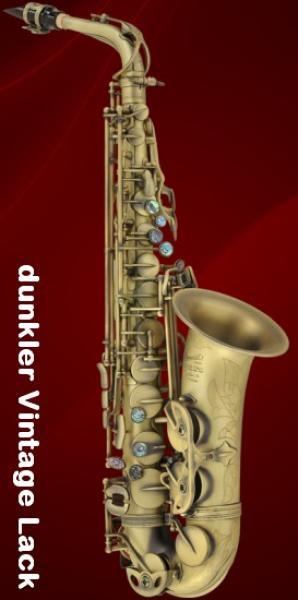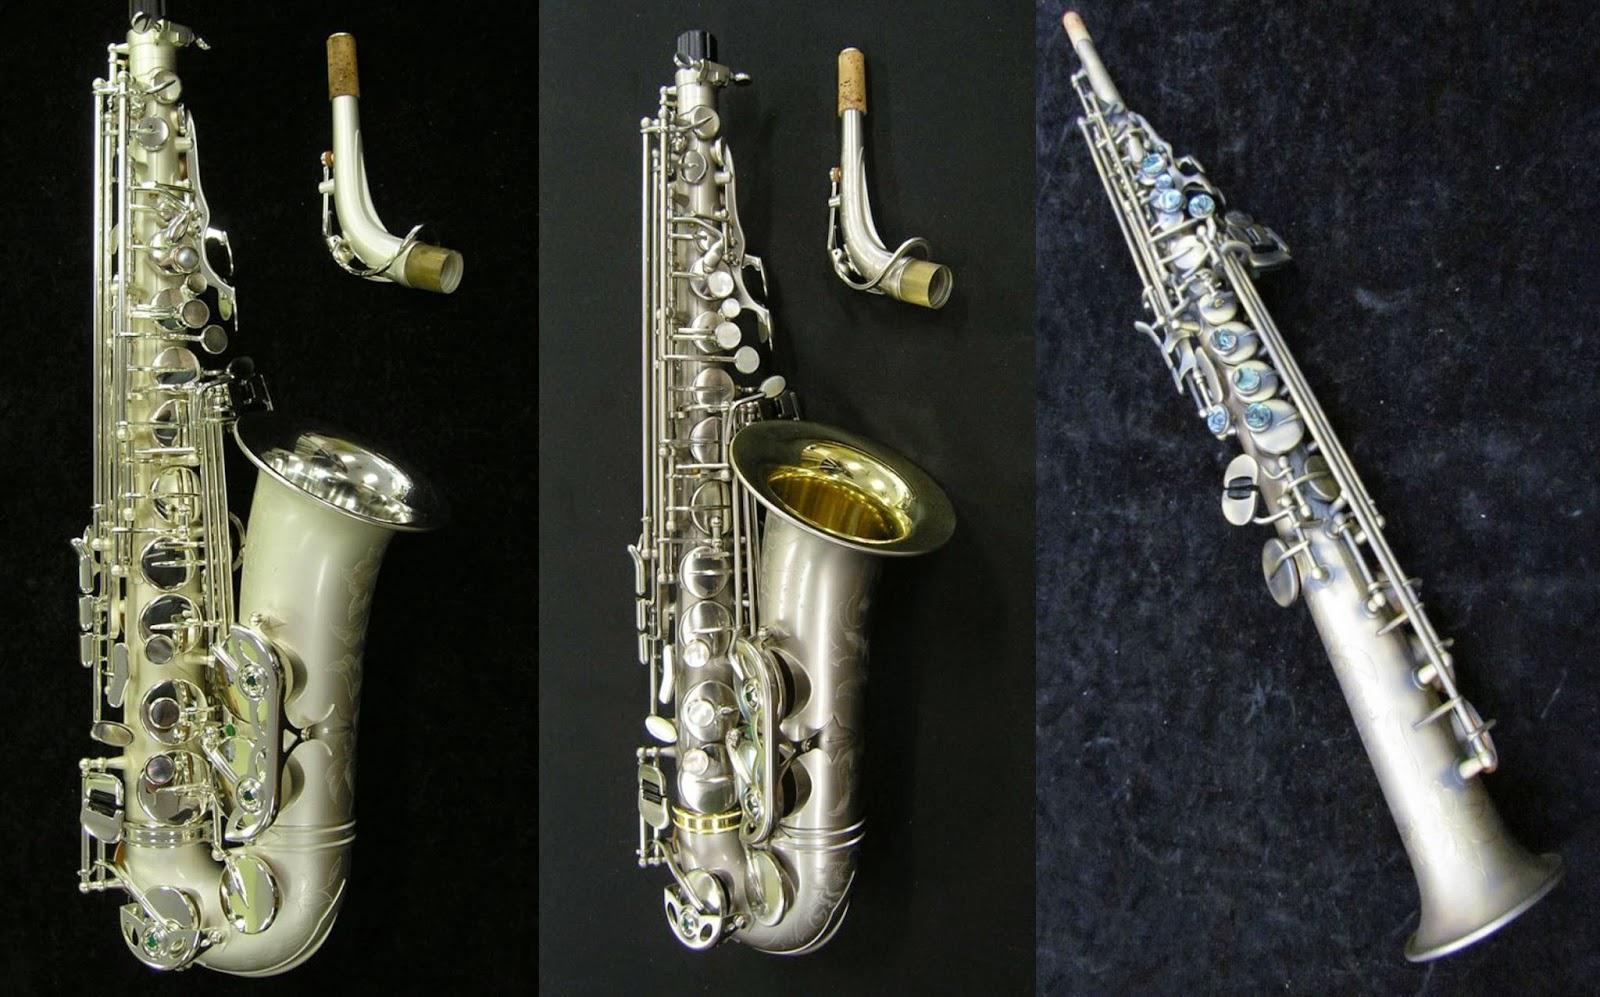The first image is the image on the left, the second image is the image on the right. Assess this claim about the two images: "In the left image, there is only one saxophone, of which you can see the entire instrument.". Correct or not? Answer yes or no. Yes. 